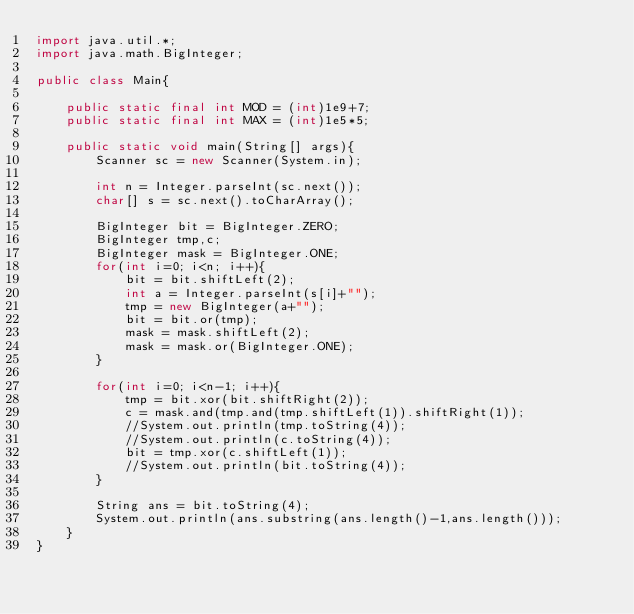Convert code to text. <code><loc_0><loc_0><loc_500><loc_500><_Java_>import java.util.*;
import java.math.BigInteger;

public class Main{
    
    public static final int MOD = (int)1e9+7;
    public static final int MAX = (int)1e5*5;
    
    public static void main(String[] args){
        Scanner sc = new Scanner(System.in);
        
        int n = Integer.parseInt(sc.next());
        char[] s = sc.next().toCharArray();
        
        BigInteger bit = BigInteger.ZERO;
        BigInteger tmp,c;
        BigInteger mask = BigInteger.ONE;
        for(int i=0; i<n; i++){
            bit = bit.shiftLeft(2);
            int a = Integer.parseInt(s[i]+"");
            tmp = new BigInteger(a+"");
            bit = bit.or(tmp);
            mask = mask.shiftLeft(2);
            mask = mask.or(BigInteger.ONE);
        }
        
        for(int i=0; i<n-1; i++){
            tmp = bit.xor(bit.shiftRight(2));
            c = mask.and(tmp.and(tmp.shiftLeft(1)).shiftRight(1));
            //System.out.println(tmp.toString(4));
            //System.out.println(c.toString(4));
            bit = tmp.xor(c.shiftLeft(1));
            //System.out.println(bit.toString(4));
        }
        
        String ans = bit.toString(4);
        System.out.println(ans.substring(ans.length()-1,ans.length()));
    }
}
</code> 